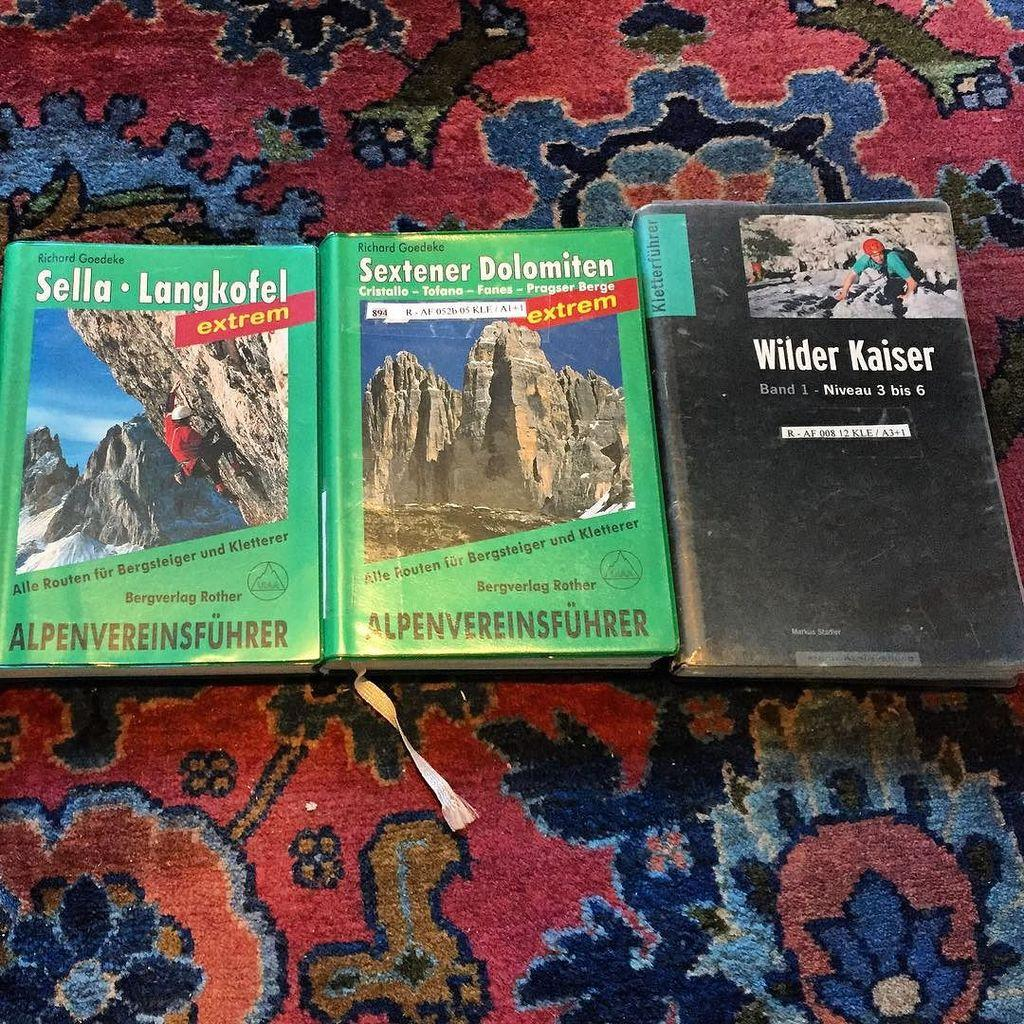<image>
Present a compact description of the photo's key features. A group of three books with two titled Sextener Dolomiten. 